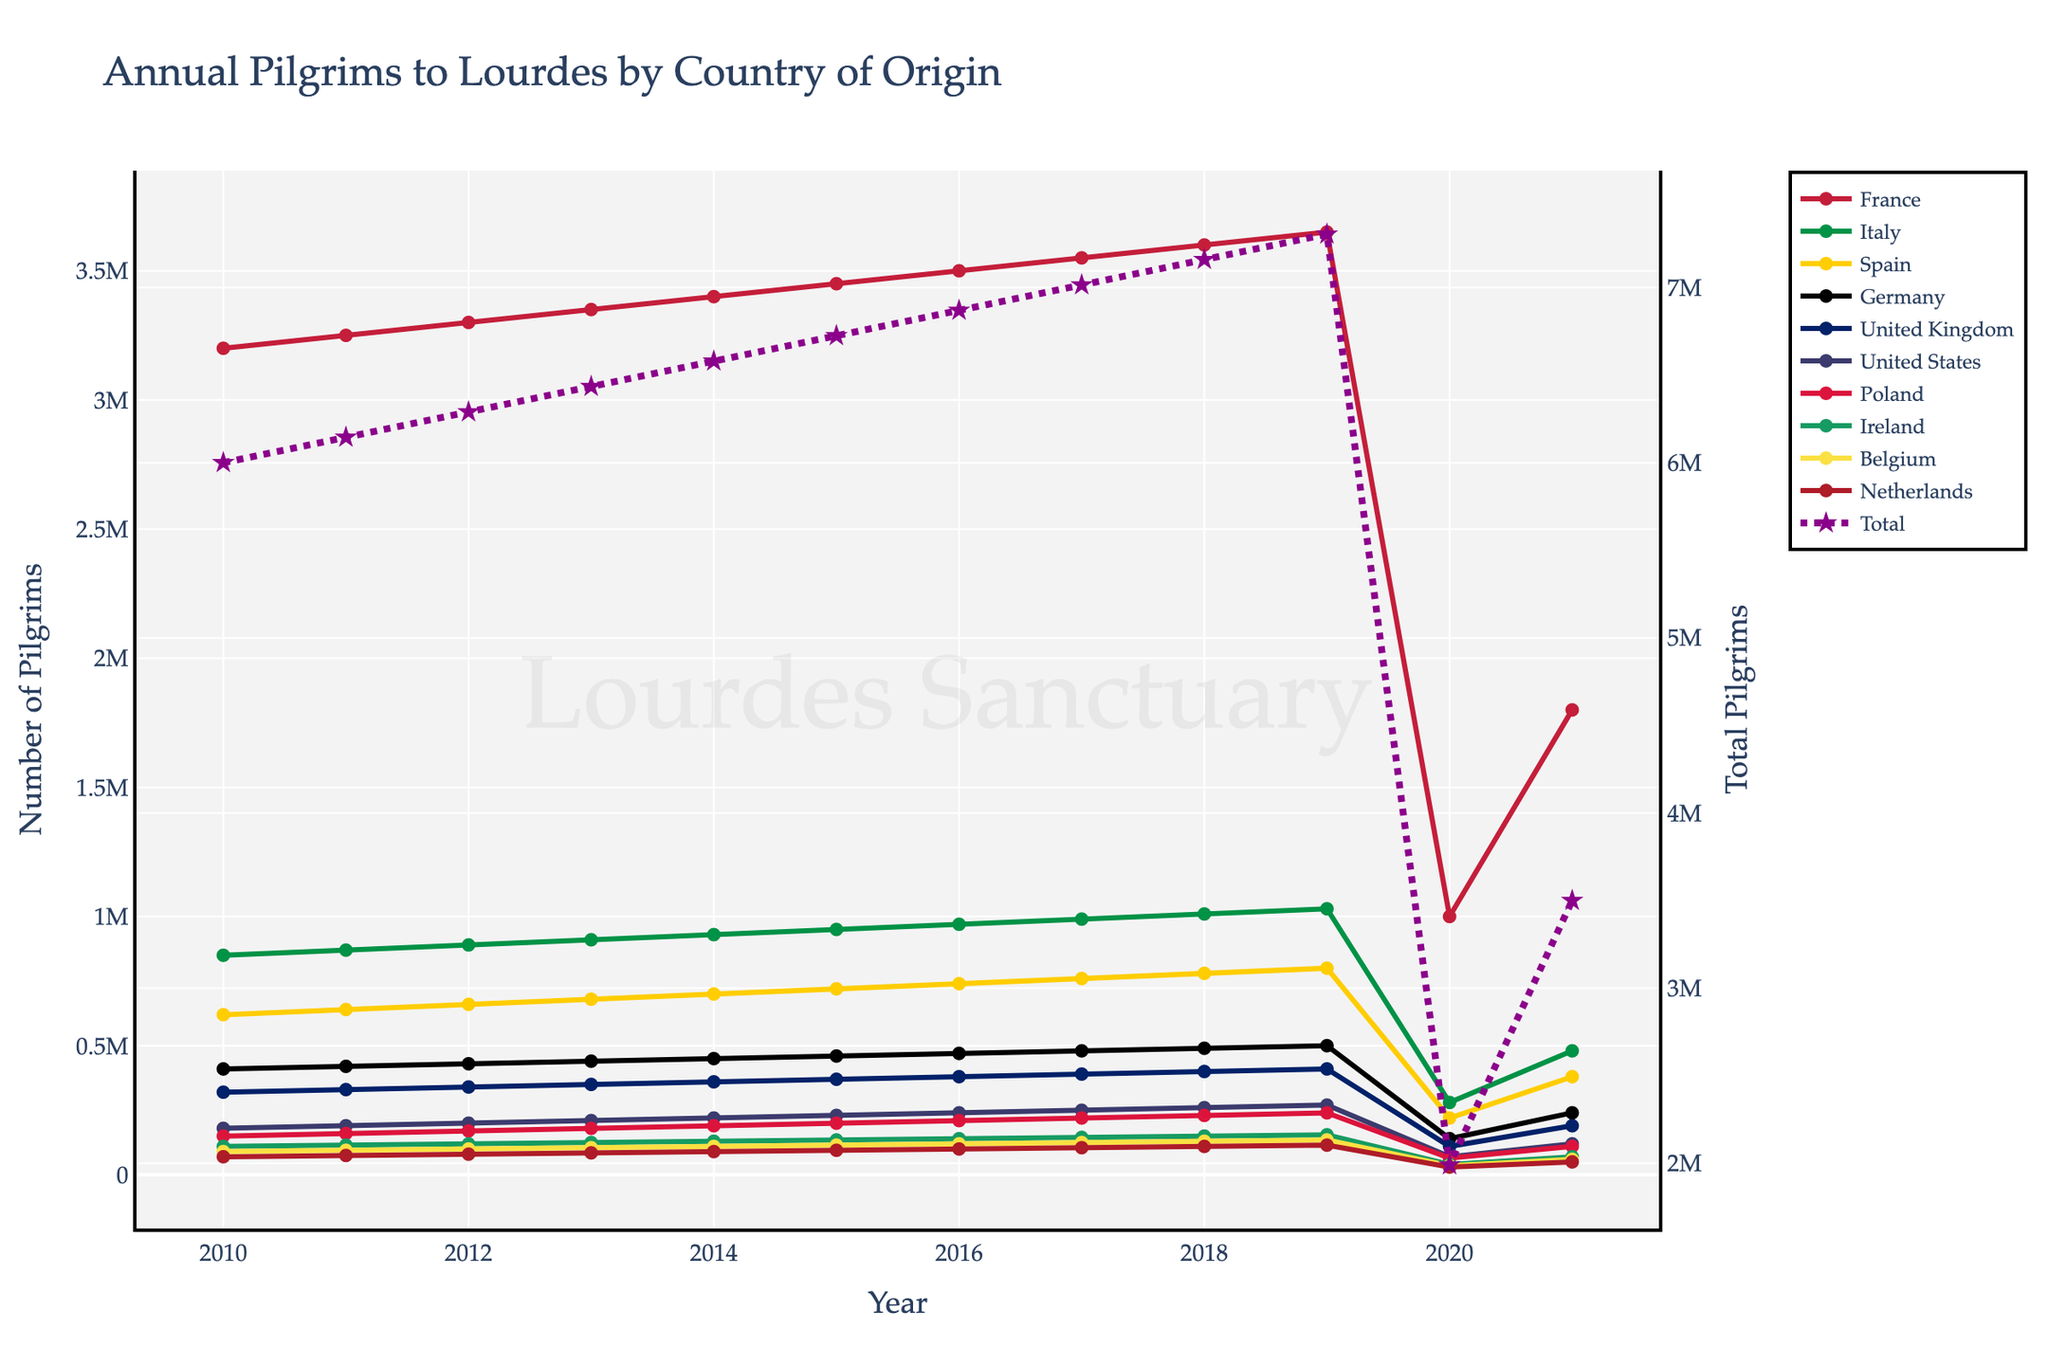What is the trend in the number of pilgrims from France between 2010 and 2019? Given that the line for France is continually rising each year from 2010 to 2019, the trend in the number of pilgrims from France shows a consistent increase over these years. Specifically, from 3,200,000 in 2010 to 3,650,000 in 2019.
Answer: Consistent increase Which country had the second highest number of pilgrims in 2017? In 2017, the second highest number of pilgrims originated from Italy, as indicated by the line for Italy being second only to France’s line.
Answer: Italy How did the total number of pilgrims in 2020 compare to 2019? By comparing the dotted 'Total' line for these years, it is clear that the total number of pilgrims in 2020 dropped significantly compared to 2019. This is especially noticeable with the drop in the height of the line, going from very tall in 2019 to quite short in 2020.
Answer: Significant decrease By how much did the number of pilgrims from the United States decrease from 2018 to 2020? The total number of pilgrims from the United States decreased from 260,000 in 2018 to 70,000 in 2020. Therefore, the decrease in pilgrims is calculated as 260,000 - 70,000, which equals 190,000.
Answer: 190,000 What's the difference in the number of pilgrims between Poland and Ireland in 2021? In 2021, Poland had 110,000 pilgrims whereas Ireland had 70,000 pilgrims. The difference can be calculated as 110,000 - 70,000 = 40,000.
Answer: 40,000 Which country shows the most dramatic decrease in the number of pilgrims from 2019 to 2020? Among all the lines for different countries, the line for France shows the most dramatic decrease from 2019 to 2020, dropping from 3,650,000 in 2019 to 1,000,000 in 2020.
Answer: France What is the total number of pilgrims visiting from Germany over the years 2015 to 2017? Summing up the number of pilgrims from Germany over these years provides 460,000 (2015) + 470,000 (2016) + 480,000 (2017) = 1,410,000.
Answer: 1,410,000 Describe the trend of the number of pilgrims from Belgium from 2010 to 2021. The number of pilgrims from Belgium shows a general increasing trend till 2019, starting from 90,000 in 2010 to 135,000 in 2019. However, there is a steep decline observed in 2020 and 2021, dropping down to 35,000 in 2020 and 60,000 in 2021.
Answer: Increase till 2019, then steep decline 